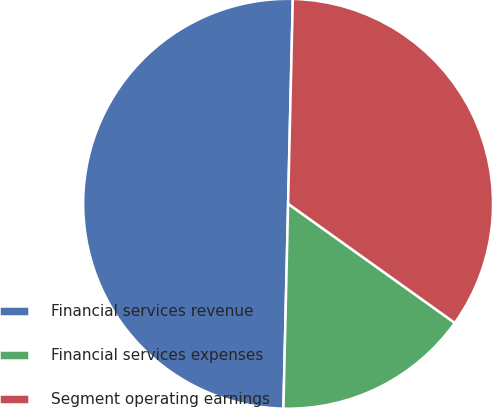Convert chart to OTSL. <chart><loc_0><loc_0><loc_500><loc_500><pie_chart><fcel>Financial services revenue<fcel>Financial services expenses<fcel>Segment operating earnings<nl><fcel>50.0%<fcel>15.49%<fcel>34.51%<nl></chart> 